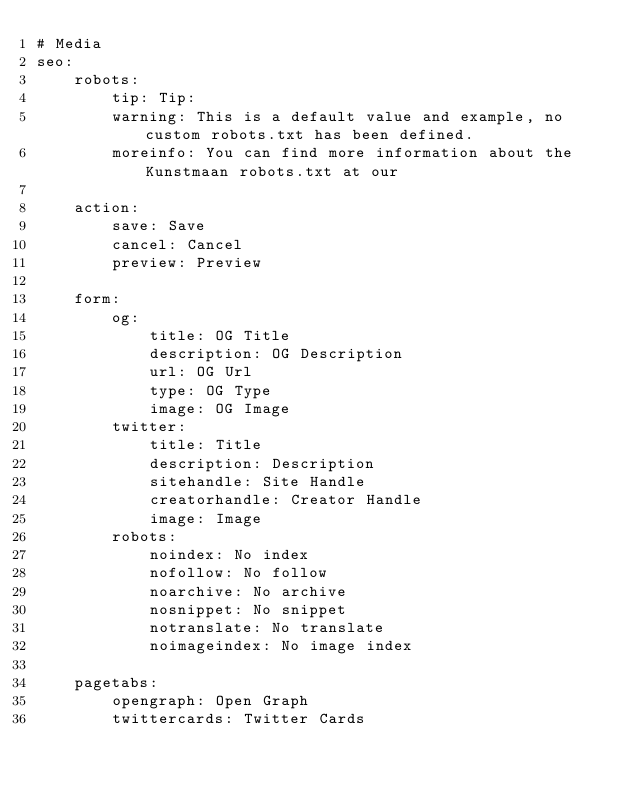Convert code to text. <code><loc_0><loc_0><loc_500><loc_500><_YAML_># Media
seo:
    robots:
        tip: Tip:
        warning: This is a default value and example, no custom robots.txt has been defined.
        moreinfo: You can find more information about the Kunstmaan robots.txt at our

    action:
        save: Save
        cancel: Cancel
        preview: Preview

    form:
        og:
            title: OG Title
            description: OG Description
            url: OG Url
            type: OG Type
            image: OG Image
        twitter:
            title: Title
            description: Description
            sitehandle: Site Handle
            creatorhandle: Creator Handle
            image: Image
        robots:
            noindex: No index
            nofollow: No follow
            noarchive: No archive
            nosnippet: No snippet
            notranslate: No translate
            noimageindex: No image index

    pagetabs:
        opengraph: Open Graph
        twittercards: Twitter Cards</code> 